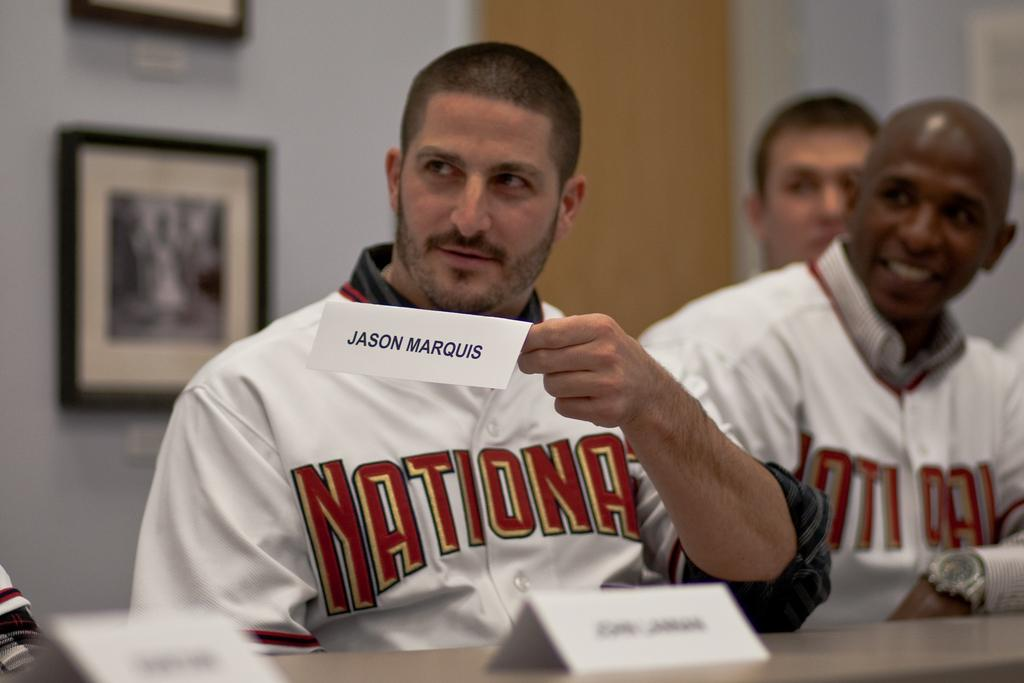<image>
Provide a brief description of the given image. a Nationals jersey on a player named Jason Marquid 